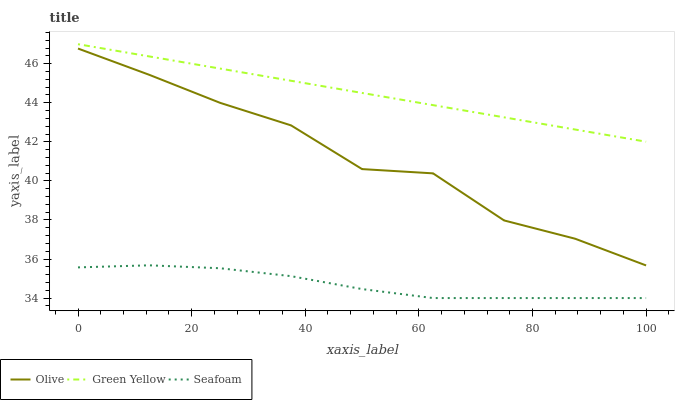Does Seafoam have the minimum area under the curve?
Answer yes or no. Yes. Does Green Yellow have the maximum area under the curve?
Answer yes or no. Yes. Does Green Yellow have the minimum area under the curve?
Answer yes or no. No. Does Seafoam have the maximum area under the curve?
Answer yes or no. No. Is Green Yellow the smoothest?
Answer yes or no. Yes. Is Olive the roughest?
Answer yes or no. Yes. Is Seafoam the smoothest?
Answer yes or no. No. Is Seafoam the roughest?
Answer yes or no. No. Does Seafoam have the lowest value?
Answer yes or no. Yes. Does Green Yellow have the lowest value?
Answer yes or no. No. Does Green Yellow have the highest value?
Answer yes or no. Yes. Does Seafoam have the highest value?
Answer yes or no. No. Is Seafoam less than Green Yellow?
Answer yes or no. Yes. Is Green Yellow greater than Seafoam?
Answer yes or no. Yes. Does Seafoam intersect Green Yellow?
Answer yes or no. No. 